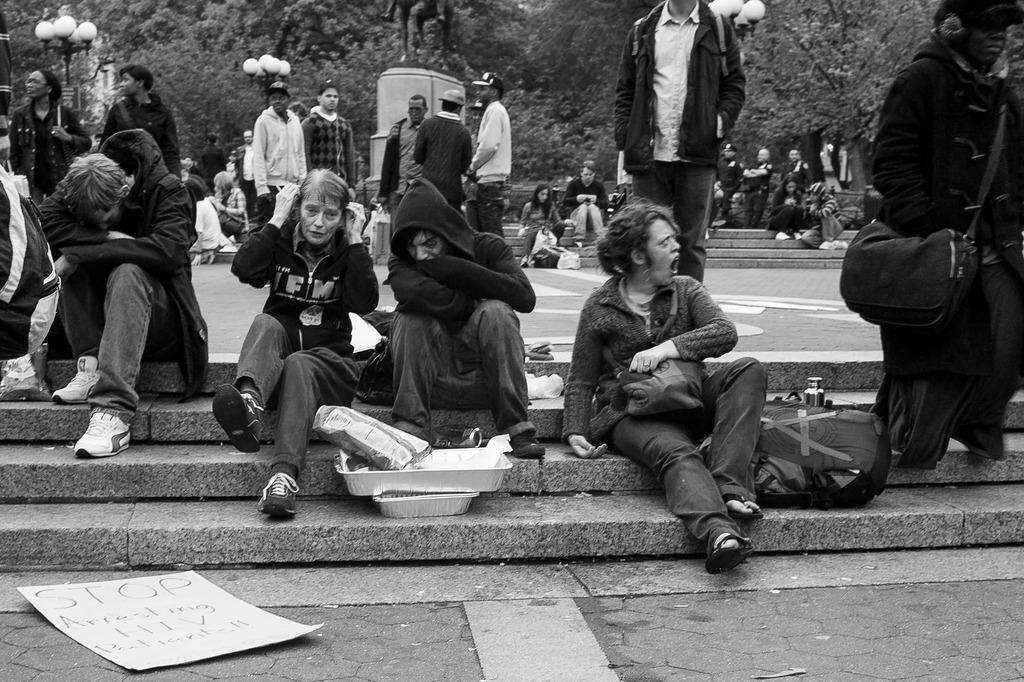In one or two sentences, can you explain what this image depicts? It is a black and white image there is a crowd gathered in an area,some of them are sitting on the steps and some of them are standing,behind these people there are plenty of trees and the crowd were protesting on some issue. 